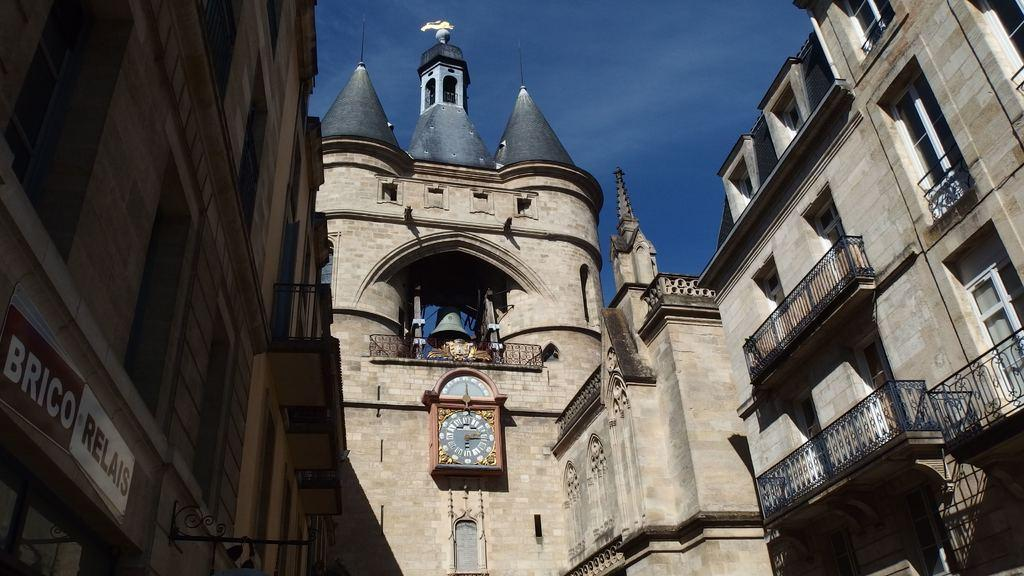What type of structures can be seen in the image? There are buildings in the image. Can you describe a specific feature of one of the buildings? There is a clock tower with a bell in the image. What type of architectural element is present in the image? There are iron grilles in the image. What is the purpose of the board in the image? The purpose of the board is not specified, but it is present in the image. What can be seen in the background of the image? The sky is visible in the background of the image. How many trails can be seen leading to the prison in the image? There is no prison present in the image, and therefore no trails leading to it. 